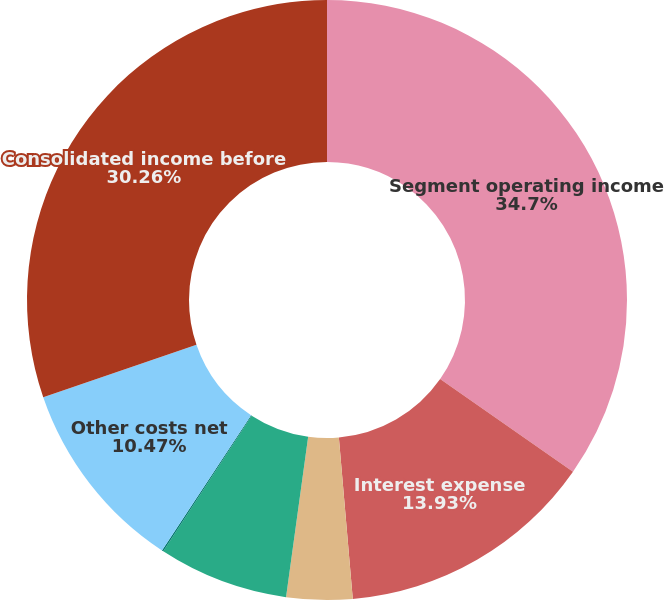<chart> <loc_0><loc_0><loc_500><loc_500><pie_chart><fcel>Segment operating income<fcel>Interest expense<fcel>Interest income<fcel>Stock-based compensation<fcel>Acquisition-related expenses<fcel>Other costs net<fcel>Consolidated income before<nl><fcel>34.7%<fcel>13.93%<fcel>3.55%<fcel>7.01%<fcel>0.08%<fcel>10.47%<fcel>30.26%<nl></chart> 